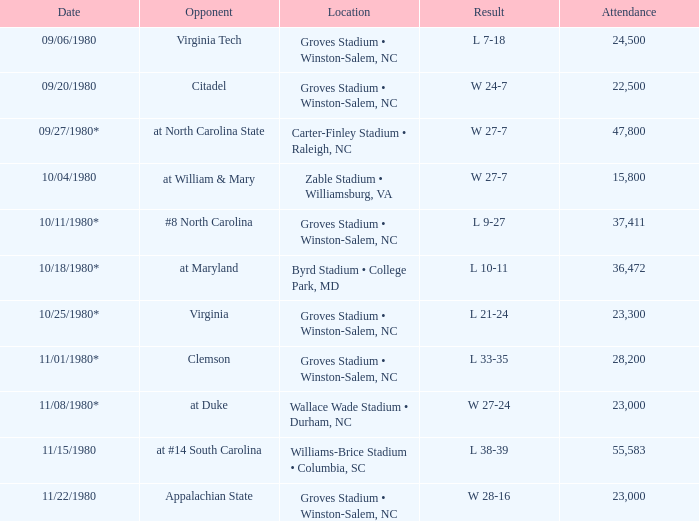What was the number of attendees at the wake forest versus virginia tech match? 24500.0. 